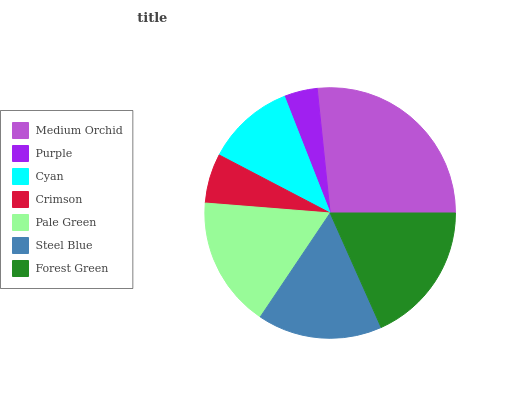Is Purple the minimum?
Answer yes or no. Yes. Is Medium Orchid the maximum?
Answer yes or no. Yes. Is Cyan the minimum?
Answer yes or no. No. Is Cyan the maximum?
Answer yes or no. No. Is Cyan greater than Purple?
Answer yes or no. Yes. Is Purple less than Cyan?
Answer yes or no. Yes. Is Purple greater than Cyan?
Answer yes or no. No. Is Cyan less than Purple?
Answer yes or no. No. Is Steel Blue the high median?
Answer yes or no. Yes. Is Steel Blue the low median?
Answer yes or no. Yes. Is Crimson the high median?
Answer yes or no. No. Is Medium Orchid the low median?
Answer yes or no. No. 